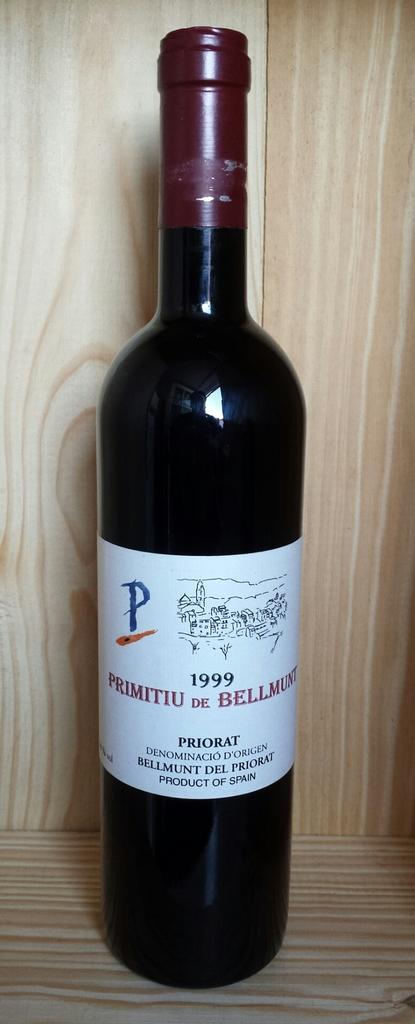Provide a one-sentence caption for the provided image. A bottle of wine from 1999 is on a table. 